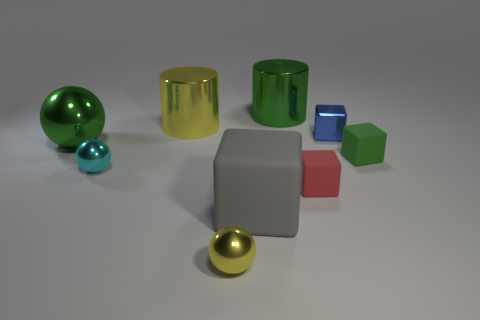Subtract all small blocks. How many blocks are left? 1 Add 1 metal objects. How many objects exist? 10 Subtract all cyan spheres. How many spheres are left? 2 Subtract 1 spheres. How many spheres are left? 2 Subtract all cylinders. How many objects are left? 7 Subtract all purple balls. Subtract all cyan cylinders. How many balls are left? 3 Subtract all big brown metallic cubes. Subtract all blue things. How many objects are left? 8 Add 6 large gray rubber cubes. How many large gray rubber cubes are left? 7 Add 3 tiny purple rubber balls. How many tiny purple rubber balls exist? 3 Subtract 0 blue spheres. How many objects are left? 9 